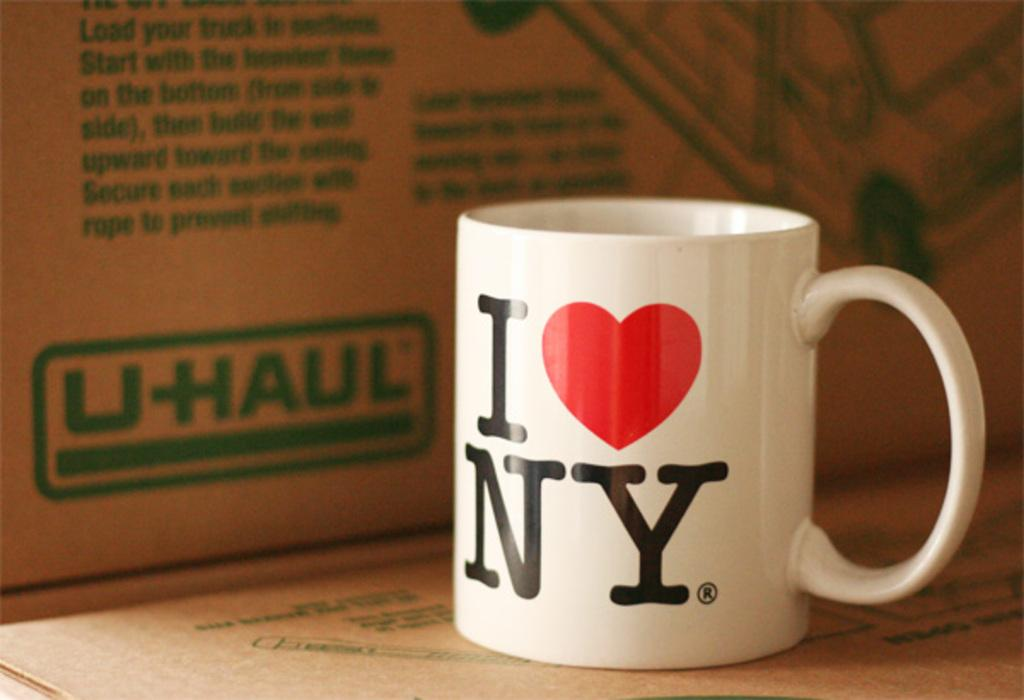What object is present in the image that can hold liquids? There is a cup in the image that can hold liquids. What is featured on the cup in the image? The cup has text and a symbol on it. What type of container is also visible in the image? There is a cardboard box in the image. What is displayed on the cardboard box in the image? The cardboard box has text and an image on it. What type of street is visible in the image? There is no street visible in the image; it only features a cup and a cardboard box. How does the cork interact with the cup in the image? There is no cork present in the image, so it cannot interact with the cup. 